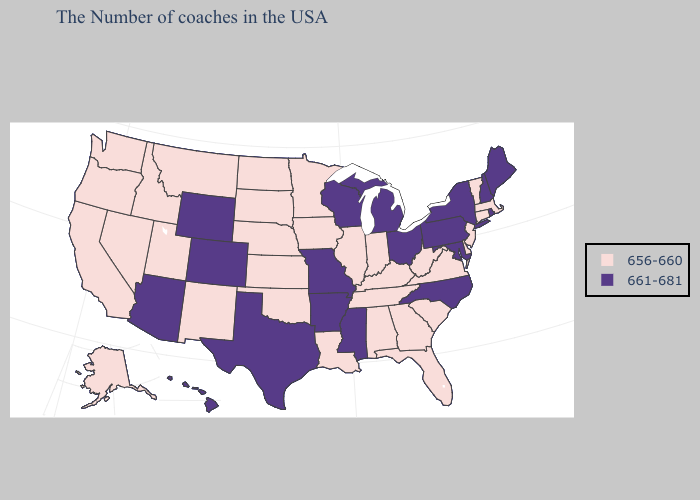Does California have the highest value in the USA?
Short answer required. No. Does Connecticut have the lowest value in the Northeast?
Write a very short answer. Yes. Among the states that border Nevada , does Arizona have the lowest value?
Write a very short answer. No. What is the lowest value in the USA?
Answer briefly. 656-660. Name the states that have a value in the range 661-681?
Short answer required. Maine, Rhode Island, New Hampshire, New York, Maryland, Pennsylvania, North Carolina, Ohio, Michigan, Wisconsin, Mississippi, Missouri, Arkansas, Texas, Wyoming, Colorado, Arizona, Hawaii. How many symbols are there in the legend?
Be succinct. 2. How many symbols are there in the legend?
Be succinct. 2. What is the value of Montana?
Short answer required. 656-660. What is the lowest value in states that border Minnesota?
Write a very short answer. 656-660. What is the lowest value in the MidWest?
Quick response, please. 656-660. Name the states that have a value in the range 661-681?
Write a very short answer. Maine, Rhode Island, New Hampshire, New York, Maryland, Pennsylvania, North Carolina, Ohio, Michigan, Wisconsin, Mississippi, Missouri, Arkansas, Texas, Wyoming, Colorado, Arizona, Hawaii. Which states have the highest value in the USA?
Concise answer only. Maine, Rhode Island, New Hampshire, New York, Maryland, Pennsylvania, North Carolina, Ohio, Michigan, Wisconsin, Mississippi, Missouri, Arkansas, Texas, Wyoming, Colorado, Arizona, Hawaii. Name the states that have a value in the range 661-681?
Give a very brief answer. Maine, Rhode Island, New Hampshire, New York, Maryland, Pennsylvania, North Carolina, Ohio, Michigan, Wisconsin, Mississippi, Missouri, Arkansas, Texas, Wyoming, Colorado, Arizona, Hawaii. What is the highest value in the Northeast ?
Short answer required. 661-681. 